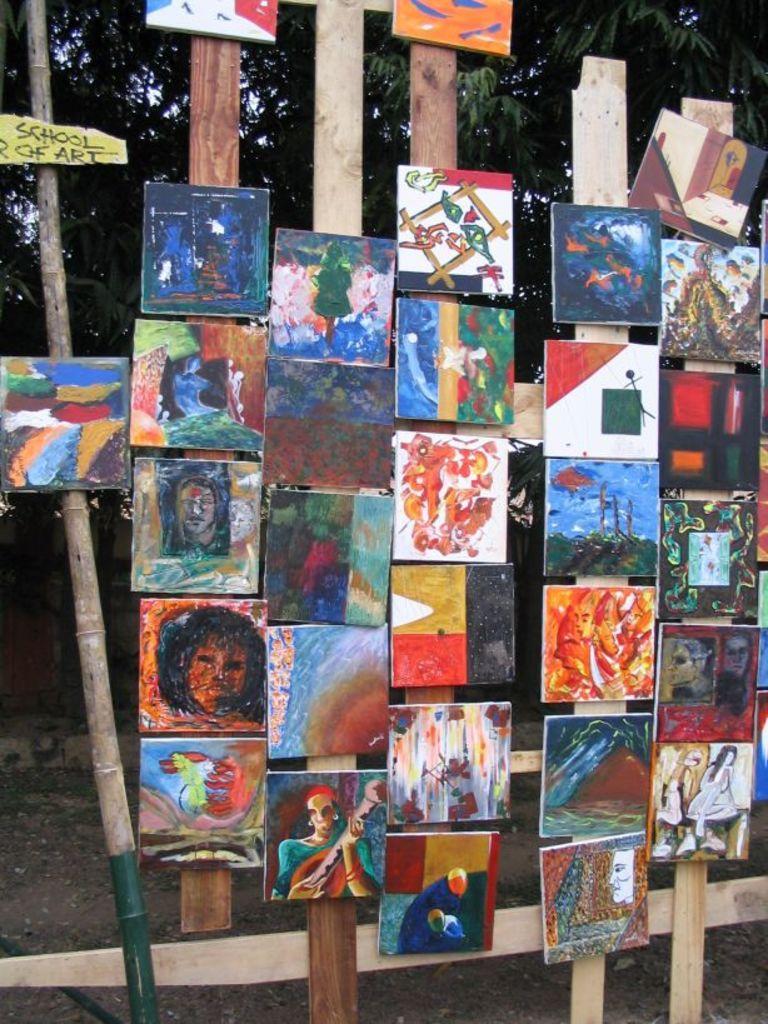Describe this image in one or two sentences. In this image there are group of photo frames, there is tree, there is ground. 